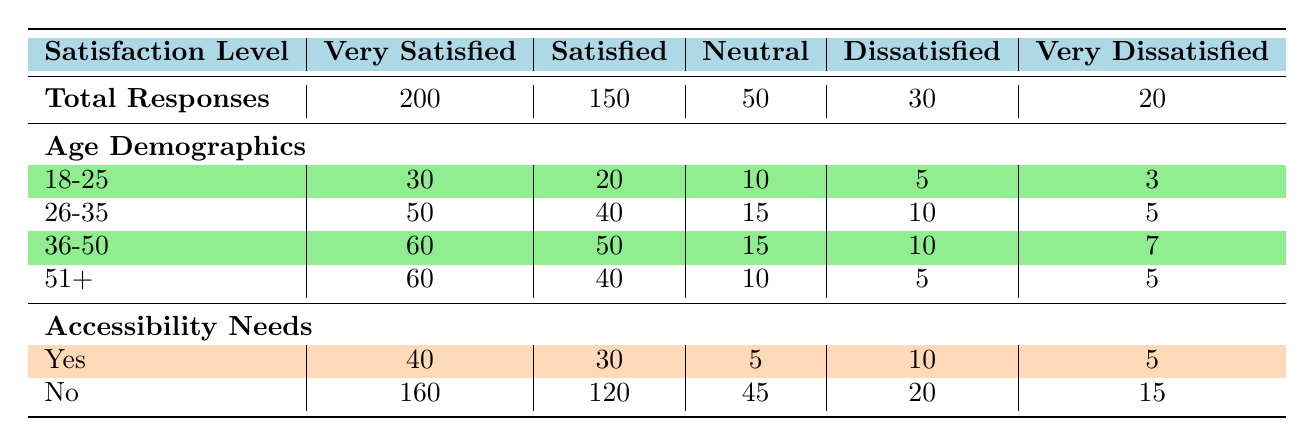What is the total number of responses from customers who were very satisfied? The table shows that the total number of responses for the "Very Satisfied" category is listed under "Total Responses". That value is 200.
Answer: 200 How many customers aged 36-50 were reported as dissatisfied? By looking at the "Dissatisfied" row under the age demographics, the number of customers aged 36-50 is 10.
Answer: 10 What is the total number of responses from customers with accessibility needs who were neutral? In the "Neutral" row under the accessibility needs demographics, the value for those who need accessibility is 5.
Answer: 5 Is the number of satisfied customers greater than the number of dissatisfied customers? The total number of satisfied customers is 150, and dissatisfied customers total 30. Since 150 is greater than 30, the answer is yes.
Answer: Yes What is the average number of very satisfied responses across all age groups? To find the average, we sum the number of very satisfied responses for each age group: 30 + 50 + 60 + 60 = 200. There are 4 age groups, so the average is 200/4 = 50.
Answer: 50 How many respondents over the age of 51 were very dissatisfied? The “Very Dissatisfied” row under age demographics indicates that there were 5 respondents aged 51 and older who were very dissatisfied.
Answer: 5 What is the difference in total responses between the very satisfied and satisfied categories? The total responses for "Very Satisfied" is 200 and for "Satisfied" is 150. The difference is 200 - 150 = 50.
Answer: 50 How many customers who identified as having accessibility needs reported being very dissatisfied? According to the "Very Dissatisfied" row under the accessibility needs demographics, 5 customers with accessibility needs reported being very dissatisfied.
Answer: 5 What percentage of customers aged 18-25 were very satisfied compared to the total number of responses from that age group? The number of very satisfied customers aged 18-25 is 30. The total number of responses in that age group is 30 + 20 + 10 + 5 + 3 = 68. The percentage is (30/68) * 100 = 44.12%.
Answer: 44.12% 